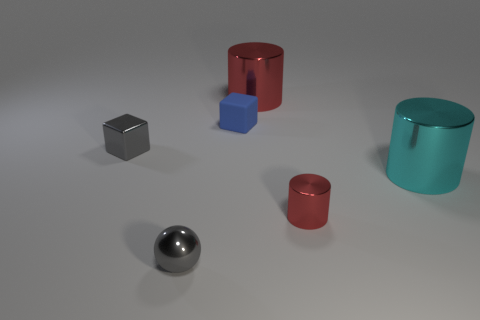How many red cylinders must be subtracted to get 1 red cylinders? 1 Subtract all red cylinders. How many cylinders are left? 1 Add 2 tiny gray blocks. How many objects exist? 8 Subtract all blocks. How many objects are left? 4 Subtract 1 cubes. How many cubes are left? 1 Subtract all gray cubes. Subtract all brown cylinders. How many cubes are left? 1 Subtract all purple balls. How many gray blocks are left? 1 Subtract all red matte blocks. Subtract all small shiny cylinders. How many objects are left? 5 Add 5 big things. How many big things are left? 7 Add 5 purple spheres. How many purple spheres exist? 5 